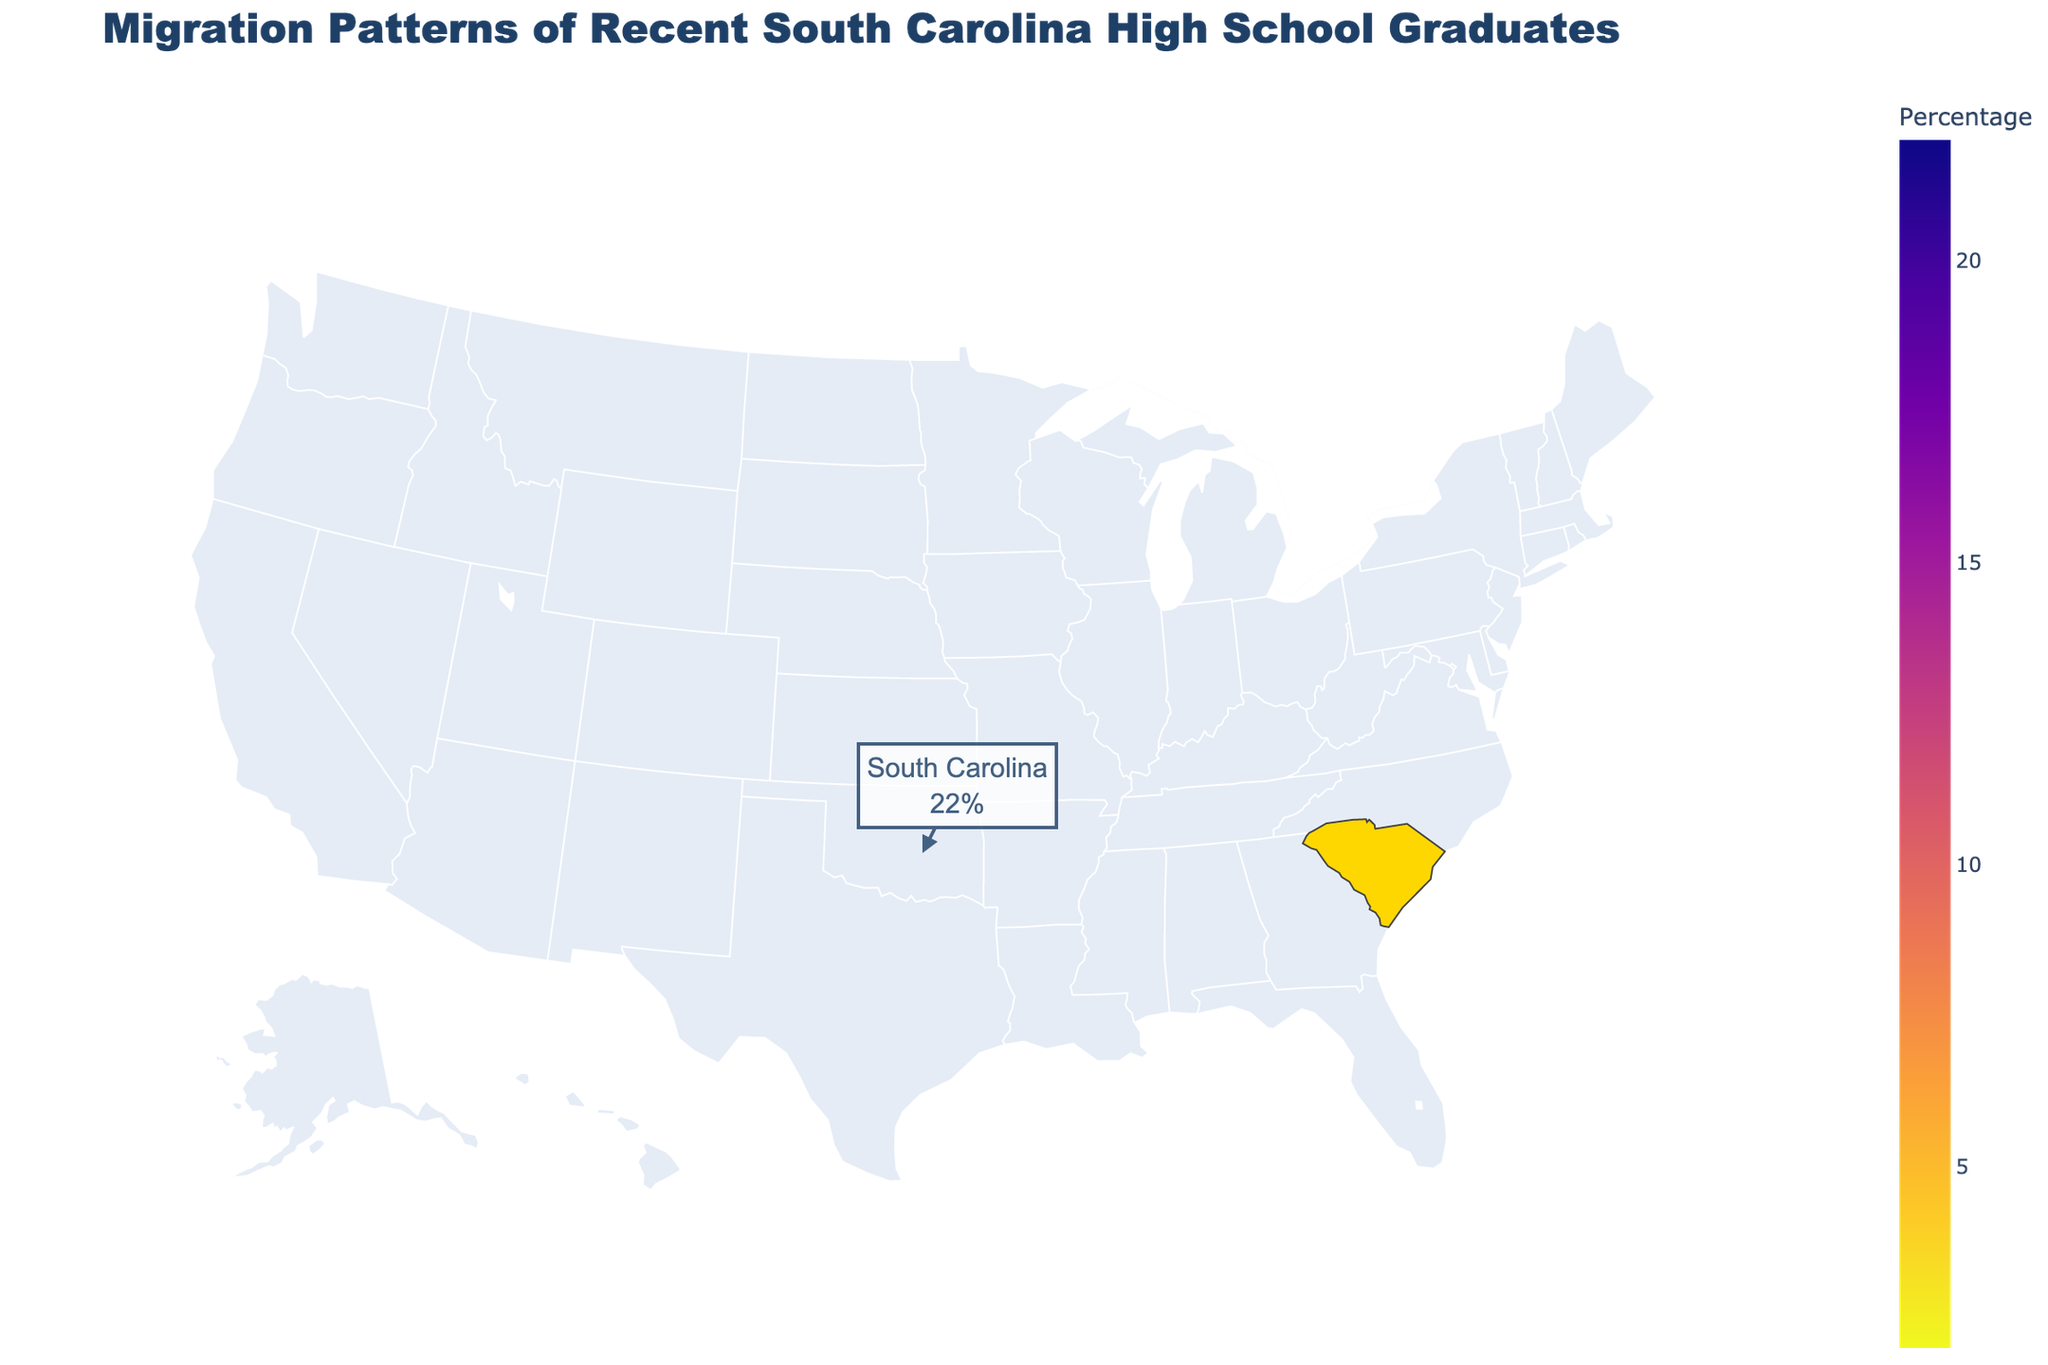What is the title of the figure? The title of the figure is usually located at the top center of a plot and provides a brief description of the data being presented. In this figure, the title is "Migration Patterns of Recent South Carolina High School Graduates."
Answer: Migration Patterns of Recent South Carolina High School Graduates Which state has the highest percentage of recent South Carolina high school graduates migrating to it? To find the state with the highest percentage, look at the legend or hover over the relevant states in the figure. South Carolina itself has the highest percentage at 22%.
Answer: South Carolina Which states have less than 5% of recent South Carolina high school graduates migrating to them? The states with less than 5% are identified by looking at the percentage values on the plot. These states are Massachusetts (4%), California (3%), Texas (3%), and Pennsylvania (2%).
Answer: Massachusetts, California, Texas, and Pennsylvania What is the combined percentage of South Carolina high school graduates migrating to North Carolina and Georgia? To calculate this, add the percentages for North Carolina (18%) and Georgia (15%). Thus, 18% + 15% = 33%.
Answer: 33% How does the percentage of graduates moving to New York compare to those moving to Florida? To compare these percentages, look at New York (8%) and Florida (12%). New York has a lower percentage than Florida.
Answer: New York is lower than Florida What is the difference in percentage between the state with the highest migration and the state with the lowest migration from South Carolina? To find the difference, take the highest percentage (22% for South Carolina) and subtract the lowest percentage (2% for Pennsylvania). Thus, 22% - 2% = 20%.
Answer: 20% Is the percentage of graduates migrating to Virginia higher or lower than to Tennessee? Look at the percentages for Virginia (7%) and Tennessee (6%). Virginia has a higher percentage than Tennessee.
Answer: Higher Which states have a percentage of recent South Carolina high school graduates migrating to them that is within 3% of Georgia's percentage? Georgia has 15%. States within 3% of 15% would have percentages from 12% to 18%. North Carolina (18%) and Florida (12%) fit this range.
Answer: North Carolina and Florida How many states have a migration percentage equal to or greater than 10%? States with percentages of 10% or more can be identified by examining the plot. These states are North Carolina (18%), Georgia (15%), and Florida (12%). So, there are three states.
Answer: 3 states Which state has a migration percentage closest to the average percentage of all listed states? First, calculate the average percentage: Sum the percentages (18+15+12+8+7+6+22+4+3+3+2=100) then divide by the number of states (11), so average is 100/11 ≈ 9.1%. New York has the closest percentage at 8%.
Answer: New York 